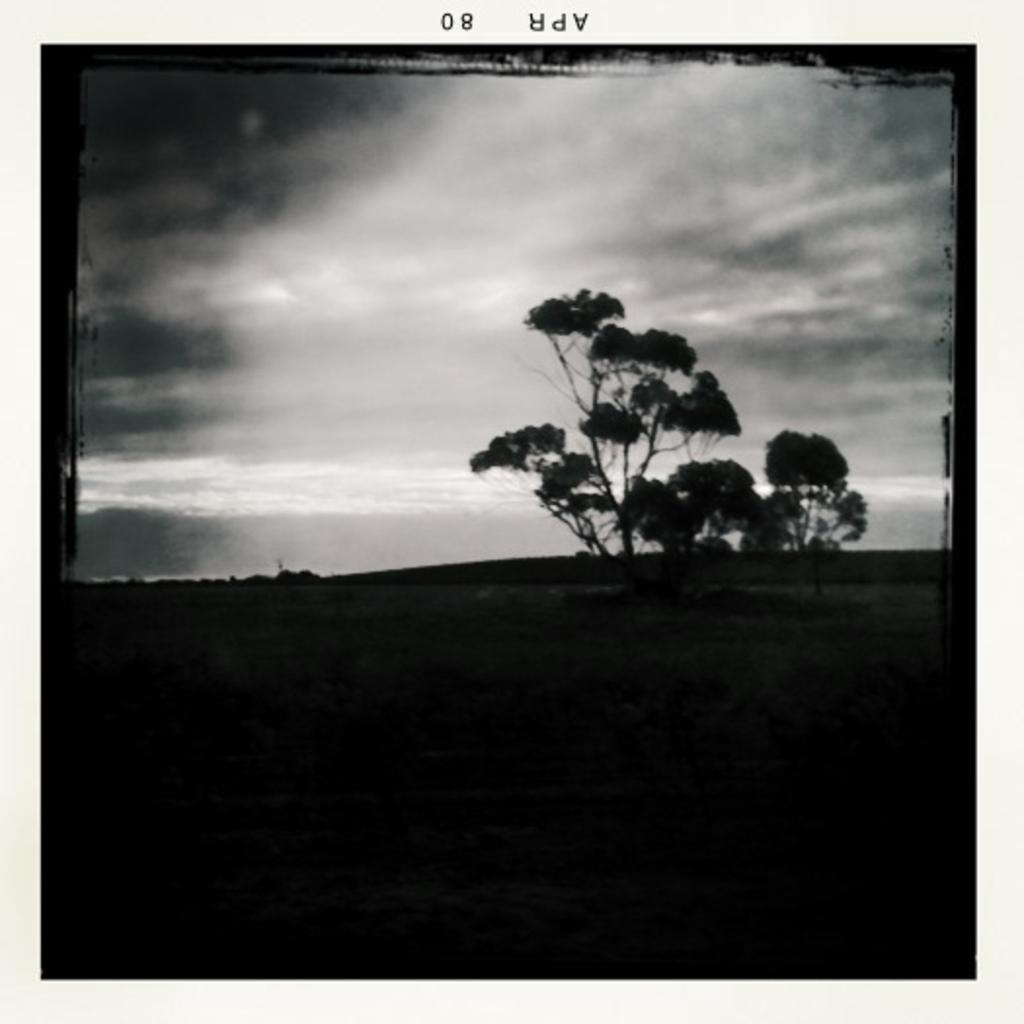What can be seen in the middle of the image? There are trees in the middle of the image. What is visible in the sky in the image? Clouds are visible in the image. What part of the natural environment is visible in the image? The sky is visible in the image. What is the head of the tree in the image? There is no head of a tree present in the image, as trees do not have heads. Is the image taken during the night? The provided facts do not mention the time of day, so it cannot be determined if the image was taken during the night. 